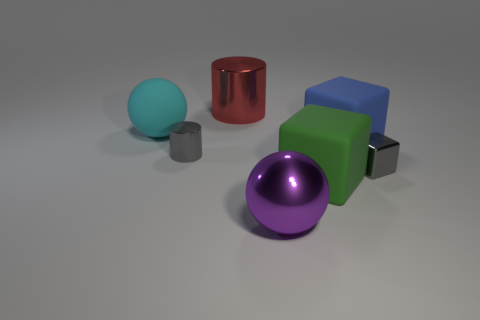Add 1 red rubber spheres. How many objects exist? 8 Subtract all cylinders. How many objects are left? 5 Add 2 green matte objects. How many green matte objects are left? 3 Add 7 small yellow metal objects. How many small yellow metal objects exist? 7 Subtract 0 yellow spheres. How many objects are left? 7 Subtract all big red matte objects. Subtract all large rubber blocks. How many objects are left? 5 